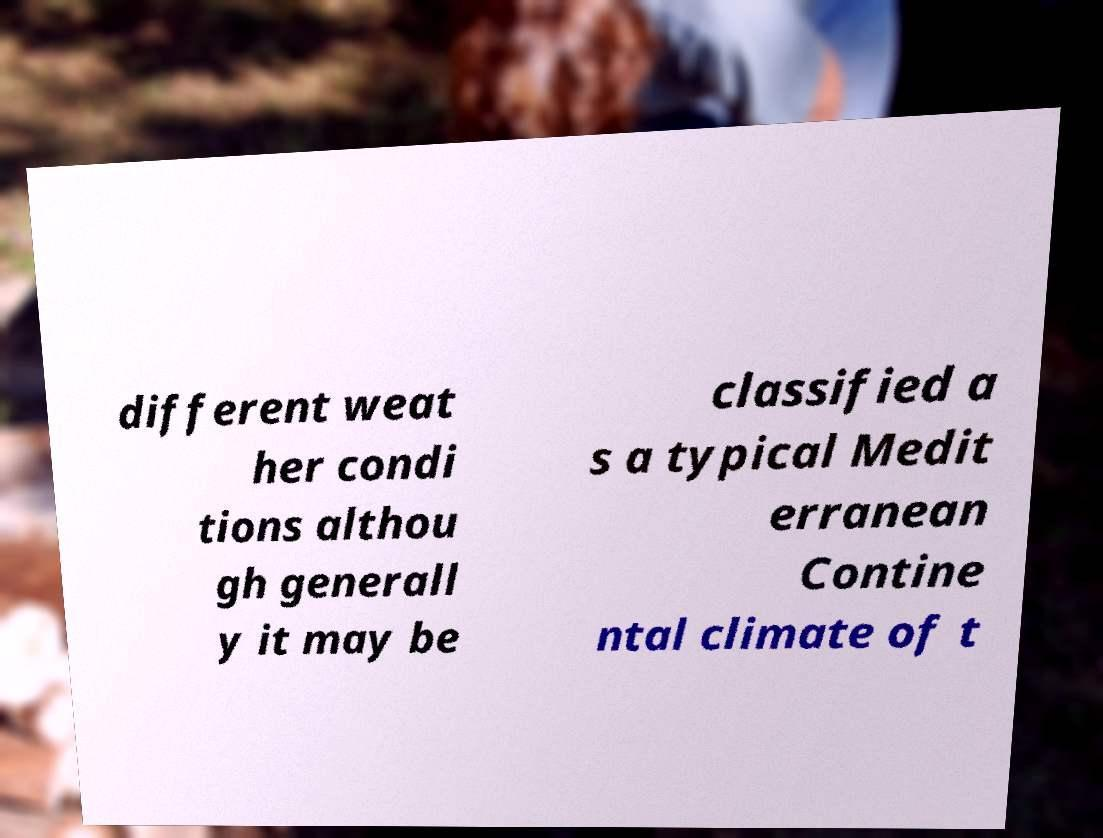Please read and relay the text visible in this image. What does it say? different weat her condi tions althou gh generall y it may be classified a s a typical Medit erranean Contine ntal climate of t 